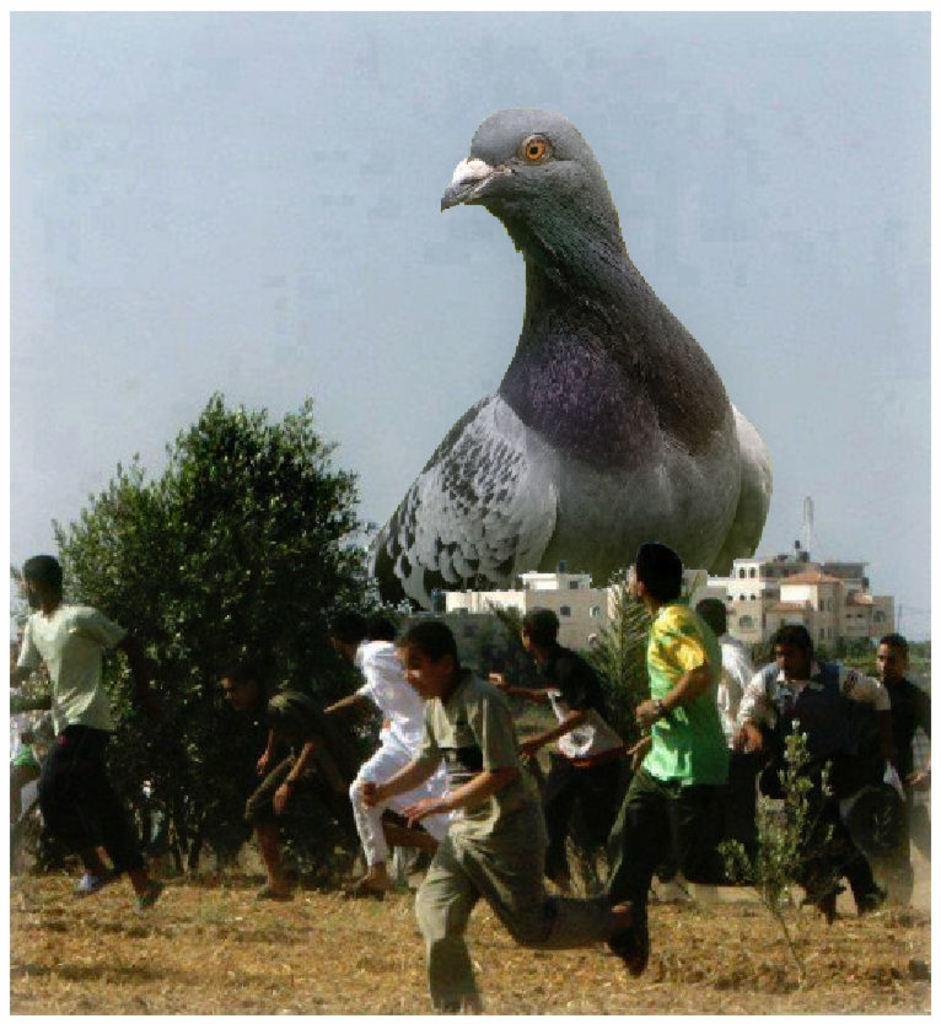In one or two sentences, can you explain what this image depicts? In this image we can see few persons are running, also see we can see some buildings, trees, a bird, also we can see the sky. 